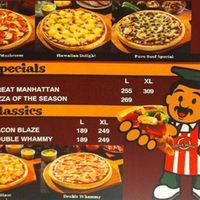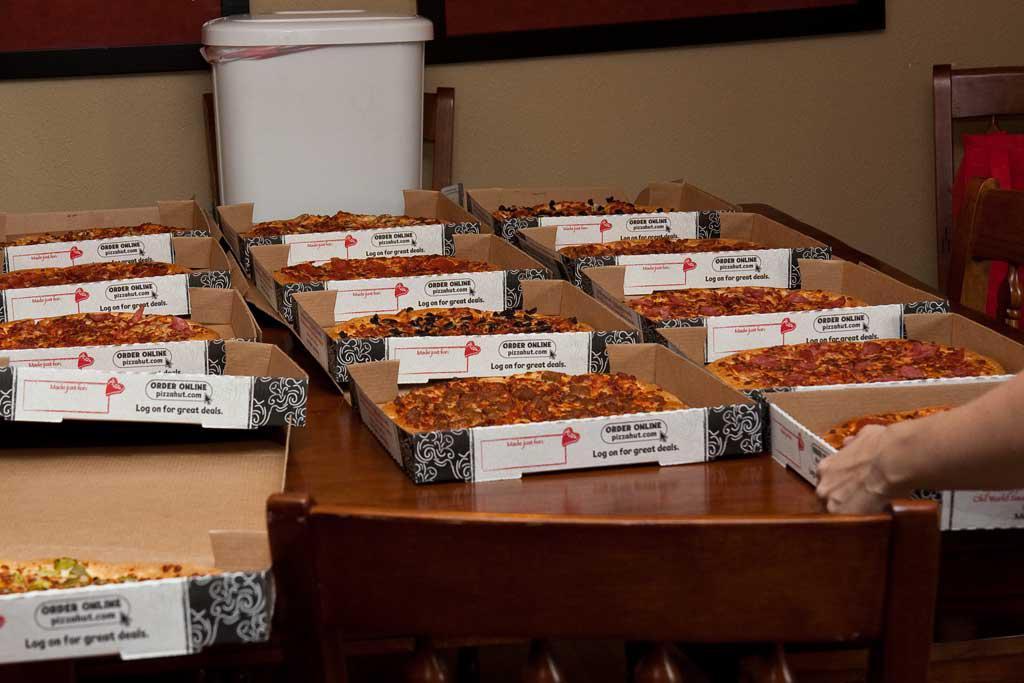The first image is the image on the left, the second image is the image on the right. Analyze the images presented: Is the assertion "All pizzas in the right image are in boxes." valid? Answer yes or no. Yes. The first image is the image on the left, the second image is the image on the right. Considering the images on both sides, is "The pizzas in the image on the right are still in their boxes." valid? Answer yes or no. Yes. 